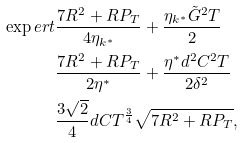Convert formula to latex. <formula><loc_0><loc_0><loc_500><loc_500>\exp e r t & \frac { 7 R ^ { 2 } + R P _ { T } } { 4 \eta _ { k ^ { * } } } + \frac { \eta _ { k ^ { * } } \tilde { G } ^ { 2 } T } { 2 } \\ & \frac { 7 R ^ { 2 } + R P _ { T } } { 2 \eta ^ { * } } + \frac { \eta ^ { * } d ^ { 2 } C ^ { 2 } T } { 2 \delta ^ { 2 } } \\ & \frac { 3 \sqrt { 2 } } { 4 } d C T ^ { \frac { 3 } { 4 } } \sqrt { 7 R ^ { 2 } + R P _ { T } } ,</formula> 